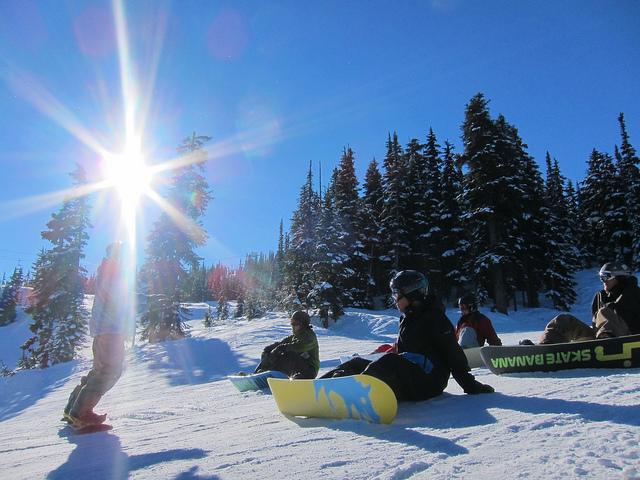What is causing the glare?
Short answer required. Sun. Is the skiers ski on the ground?
Write a very short answer. Yes. What is on the bottom of the boys snowboard?
Write a very short answer. Wolf. What is strapped to the people's feet?
Quick response, please. Snowboards. 